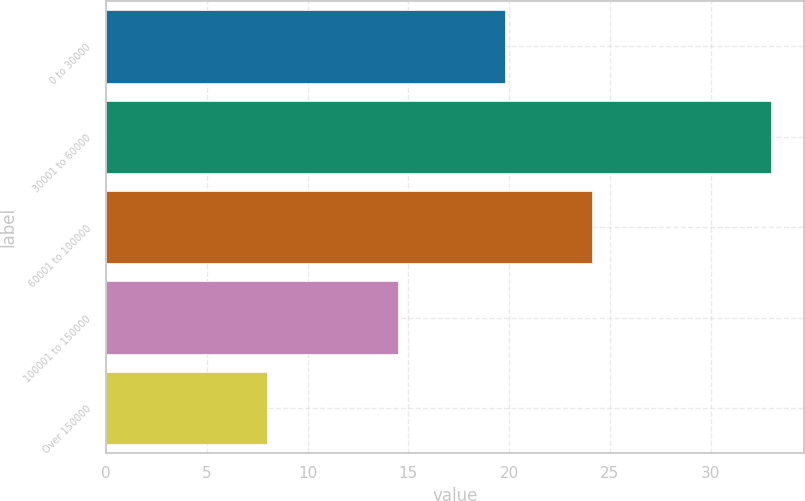Convert chart. <chart><loc_0><loc_0><loc_500><loc_500><bar_chart><fcel>0 to 30000<fcel>30001 to 60000<fcel>60001 to 100000<fcel>100001 to 150000<fcel>Over 150000<nl><fcel>19.8<fcel>33<fcel>24.1<fcel>14.5<fcel>8<nl></chart> 